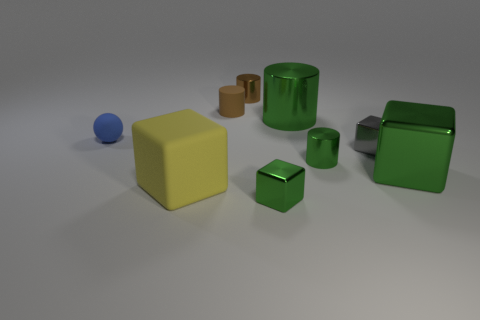Subtract 1 cubes. How many cubes are left? 3 Subtract all purple balls. Subtract all brown cubes. How many balls are left? 1 Add 1 large metallic blocks. How many objects exist? 10 Subtract all cylinders. How many objects are left? 5 Subtract 1 yellow cubes. How many objects are left? 8 Subtract all tiny things. Subtract all large red matte cylinders. How many objects are left? 3 Add 6 balls. How many balls are left? 7 Add 1 purple metallic spheres. How many purple metallic spheres exist? 1 